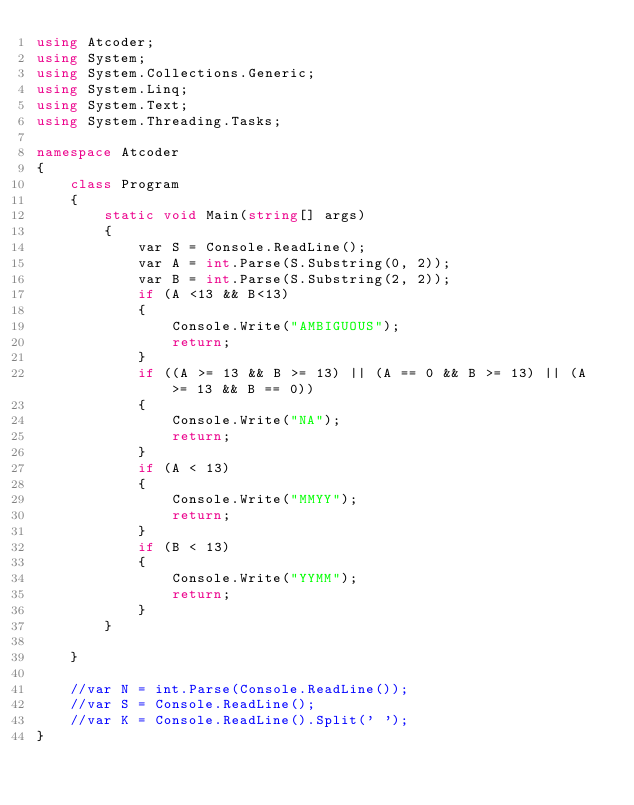Convert code to text. <code><loc_0><loc_0><loc_500><loc_500><_C#_>using Atcoder;
using System;
using System.Collections.Generic;
using System.Linq;
using System.Text;
using System.Threading.Tasks;

namespace Atcoder
{
    class Program
    {
        static void Main(string[] args)
        {
            var S = Console.ReadLine();
            var A = int.Parse(S.Substring(0, 2));
            var B = int.Parse(S.Substring(2, 2));
            if (A <13 && B<13)
            {
                Console.Write("AMBIGUOUS");
                return;
            }
            if ((A >= 13 && B >= 13) || (A == 0 && B >= 13) || (A >= 13 && B == 0))
            {
                Console.Write("NA");
                return;
            }
            if (A < 13)
            {
                Console.Write("MMYY");
                return;
            }
            if (B < 13)
            {
                Console.Write("YYMM");
                return;
            }
        }

    }

    //var N = int.Parse(Console.ReadLine());
    //var S = Console.ReadLine();
    //var K = Console.ReadLine().Split(' ');
}
</code> 